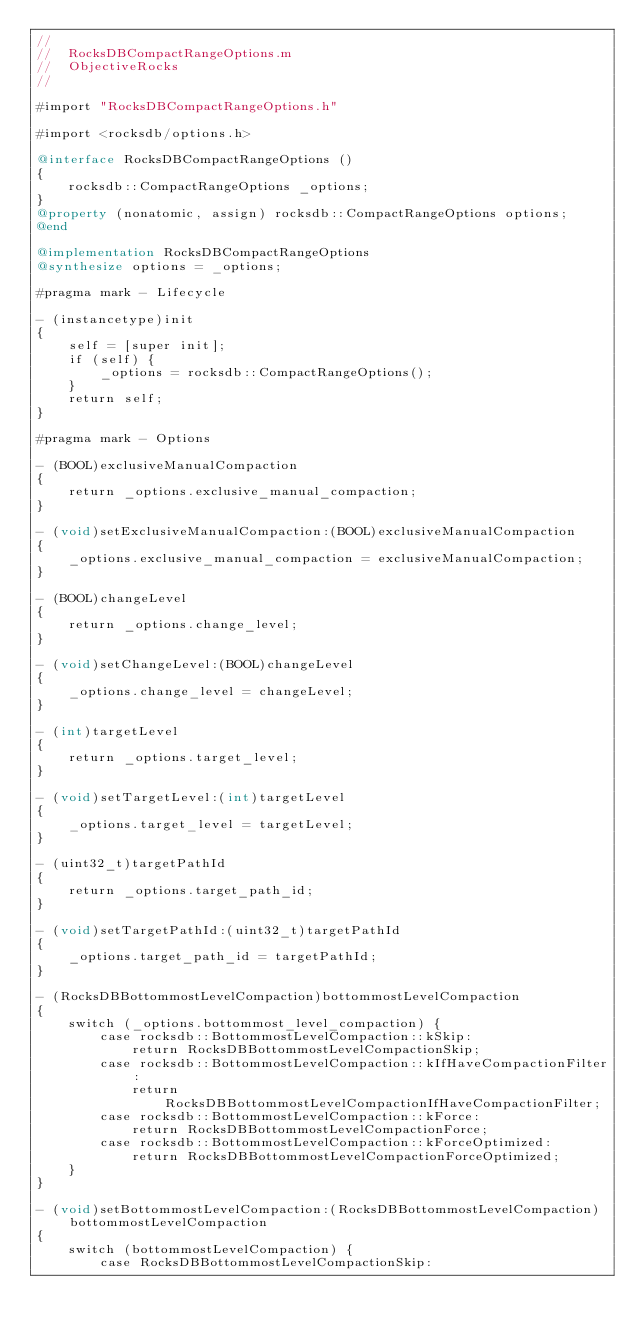<code> <loc_0><loc_0><loc_500><loc_500><_ObjectiveC_>//
//  RocksDBCompactRangeOptions.m
//  ObjectiveRocks
//

#import "RocksDBCompactRangeOptions.h"

#import <rocksdb/options.h>

@interface RocksDBCompactRangeOptions ()
{
	rocksdb::CompactRangeOptions _options;
}
@property (nonatomic, assign) rocksdb::CompactRangeOptions options;
@end

@implementation RocksDBCompactRangeOptions
@synthesize options = _options;

#pragma mark - Lifecycle

- (instancetype)init
{
	self = [super init];
	if (self) {
		_options = rocksdb::CompactRangeOptions();
	}
	return self;
}

#pragma mark - Options

- (BOOL)exclusiveManualCompaction
{
	return _options.exclusive_manual_compaction;
}

- (void)setExclusiveManualCompaction:(BOOL)exclusiveManualCompaction
{
	_options.exclusive_manual_compaction = exclusiveManualCompaction;
}

- (BOOL)changeLevel
{
	return _options.change_level;
}

- (void)setChangeLevel:(BOOL)changeLevel
{
	_options.change_level = changeLevel;
}

- (int)targetLevel
{
	return _options.target_level;
}

- (void)setTargetLevel:(int)targetLevel
{
	_options.target_level = targetLevel;
}

- (uint32_t)targetPathId
{
	return _options.target_path_id;
}

- (void)setTargetPathId:(uint32_t)targetPathId
{
	_options.target_path_id = targetPathId;
}

- (RocksDBBottommostLevelCompaction)bottommostLevelCompaction
{
	switch (_options.bottommost_level_compaction) {
		case rocksdb::BottommostLevelCompaction::kSkip:
			return RocksDBBottommostLevelCompactionSkip;
		case rocksdb::BottommostLevelCompaction::kIfHaveCompactionFilter:
			return RocksDBBottommostLevelCompactionIfHaveCompactionFilter;
		case rocksdb::BottommostLevelCompaction::kForce:
			return RocksDBBottommostLevelCompactionForce;
		case rocksdb::BottommostLevelCompaction::kForceOptimized:
			return RocksDBBottommostLevelCompactionForceOptimized;
	}
}

- (void)setBottommostLevelCompaction:(RocksDBBottommostLevelCompaction)bottommostLevelCompaction
{
	switch (bottommostLevelCompaction) {
		case RocksDBBottommostLevelCompactionSkip:</code> 